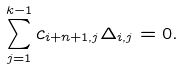Convert formula to latex. <formula><loc_0><loc_0><loc_500><loc_500>\sum _ { j = 1 } ^ { k - 1 } c _ { i + n + 1 , j } \Delta _ { i , j } = 0 .</formula> 